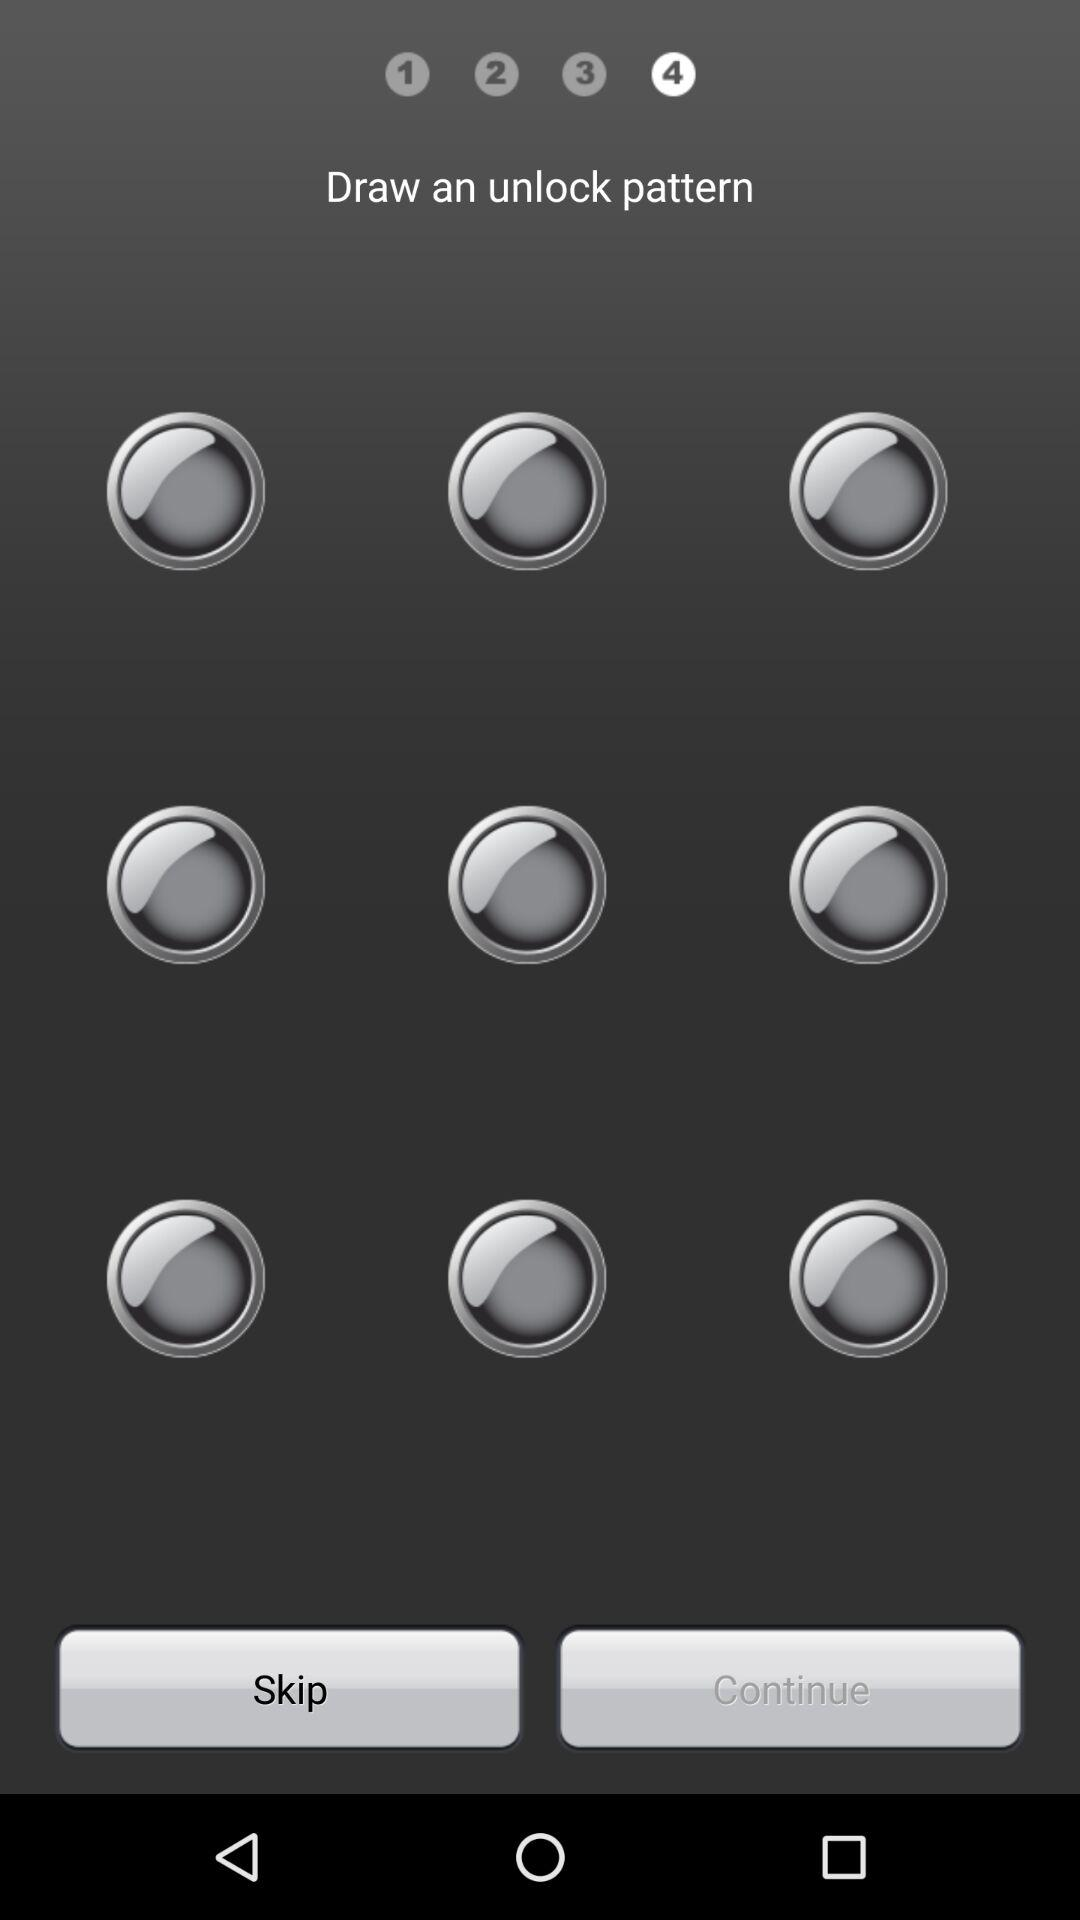How many steps in total are there? There are 4 steps in total. 